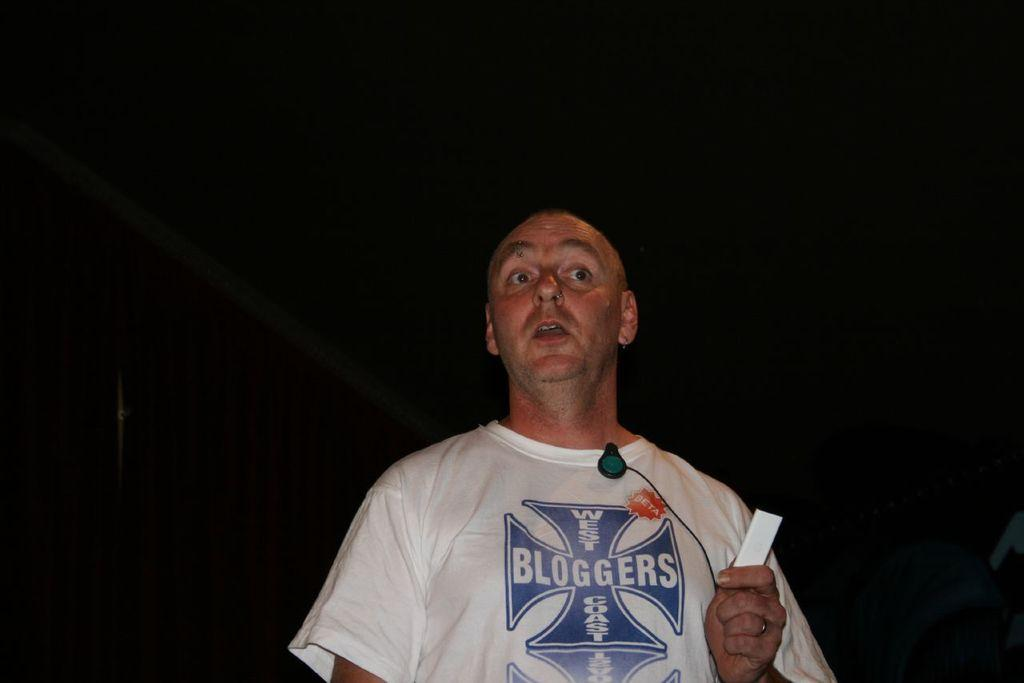Who is present in the image? There is a man in the image. What is the man holding in the image? The man is holding a paper. What is the man wearing in the image? The man is wearing a white t-shirt. What can be observed about the background of the image? The background of the image is dark. What type of bead is the man using to take the picture in the image? There is no camera or bead present in the image; the man is simply holding a paper. 